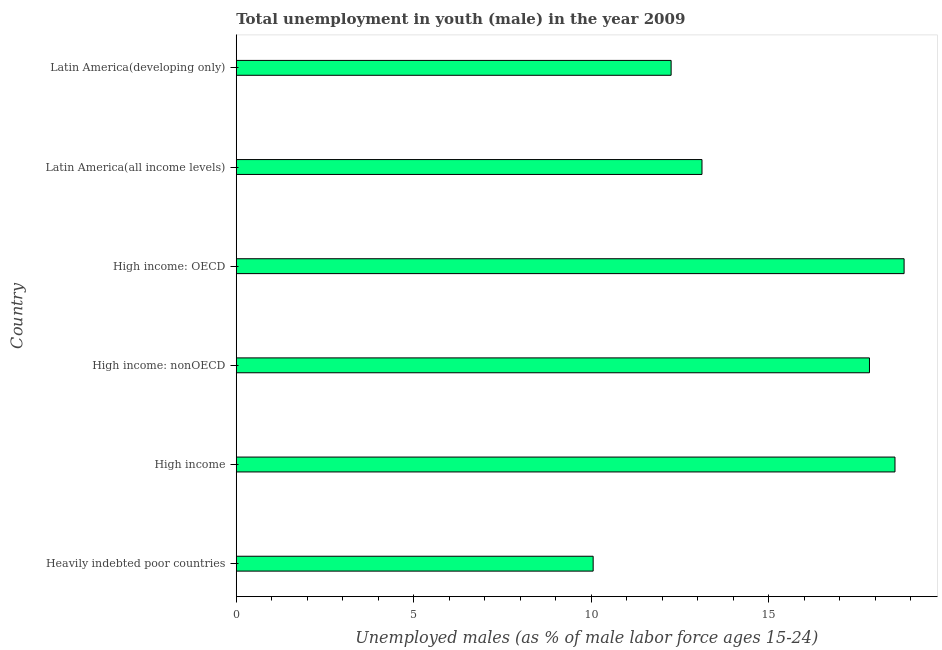Does the graph contain any zero values?
Offer a terse response. No. What is the title of the graph?
Provide a succinct answer. Total unemployment in youth (male) in the year 2009. What is the label or title of the X-axis?
Make the answer very short. Unemployed males (as % of male labor force ages 15-24). What is the unemployed male youth population in Latin America(developing only)?
Ensure brevity in your answer.  12.25. Across all countries, what is the maximum unemployed male youth population?
Make the answer very short. 18.81. Across all countries, what is the minimum unemployed male youth population?
Your answer should be very brief. 10.05. In which country was the unemployed male youth population maximum?
Give a very brief answer. High income: OECD. In which country was the unemployed male youth population minimum?
Make the answer very short. Heavily indebted poor countries. What is the sum of the unemployed male youth population?
Provide a succinct answer. 90.61. What is the difference between the unemployed male youth population in High income and Latin America(developing only)?
Ensure brevity in your answer.  6.3. What is the average unemployed male youth population per country?
Your response must be concise. 15.1. What is the median unemployed male youth population?
Offer a terse response. 15.47. In how many countries, is the unemployed male youth population greater than 17 %?
Your answer should be compact. 3. What is the ratio of the unemployed male youth population in High income to that in Latin America(developing only)?
Make the answer very short. 1.51. What is the difference between the highest and the second highest unemployed male youth population?
Your answer should be very brief. 0.26. Is the sum of the unemployed male youth population in Latin America(all income levels) and Latin America(developing only) greater than the maximum unemployed male youth population across all countries?
Provide a succinct answer. Yes. What is the difference between the highest and the lowest unemployed male youth population?
Give a very brief answer. 8.76. Are all the bars in the graph horizontal?
Give a very brief answer. Yes. Are the values on the major ticks of X-axis written in scientific E-notation?
Ensure brevity in your answer.  No. What is the Unemployed males (as % of male labor force ages 15-24) of Heavily indebted poor countries?
Provide a succinct answer. 10.05. What is the Unemployed males (as % of male labor force ages 15-24) of High income?
Give a very brief answer. 18.55. What is the Unemployed males (as % of male labor force ages 15-24) of High income: nonOECD?
Ensure brevity in your answer.  17.83. What is the Unemployed males (as % of male labor force ages 15-24) in High income: OECD?
Ensure brevity in your answer.  18.81. What is the Unemployed males (as % of male labor force ages 15-24) of Latin America(all income levels)?
Provide a short and direct response. 13.12. What is the Unemployed males (as % of male labor force ages 15-24) in Latin America(developing only)?
Provide a short and direct response. 12.25. What is the difference between the Unemployed males (as % of male labor force ages 15-24) in Heavily indebted poor countries and High income?
Make the answer very short. -8.5. What is the difference between the Unemployed males (as % of male labor force ages 15-24) in Heavily indebted poor countries and High income: nonOECD?
Make the answer very short. -7.78. What is the difference between the Unemployed males (as % of male labor force ages 15-24) in Heavily indebted poor countries and High income: OECD?
Provide a short and direct response. -8.76. What is the difference between the Unemployed males (as % of male labor force ages 15-24) in Heavily indebted poor countries and Latin America(all income levels)?
Give a very brief answer. -3.06. What is the difference between the Unemployed males (as % of male labor force ages 15-24) in Heavily indebted poor countries and Latin America(developing only)?
Your response must be concise. -2.2. What is the difference between the Unemployed males (as % of male labor force ages 15-24) in High income and High income: nonOECD?
Provide a short and direct response. 0.72. What is the difference between the Unemployed males (as % of male labor force ages 15-24) in High income and High income: OECD?
Provide a succinct answer. -0.26. What is the difference between the Unemployed males (as % of male labor force ages 15-24) in High income and Latin America(all income levels)?
Offer a terse response. 5.44. What is the difference between the Unemployed males (as % of male labor force ages 15-24) in High income and Latin America(developing only)?
Keep it short and to the point. 6.3. What is the difference between the Unemployed males (as % of male labor force ages 15-24) in High income: nonOECD and High income: OECD?
Keep it short and to the point. -0.98. What is the difference between the Unemployed males (as % of male labor force ages 15-24) in High income: nonOECD and Latin America(all income levels)?
Offer a terse response. 4.72. What is the difference between the Unemployed males (as % of male labor force ages 15-24) in High income: nonOECD and Latin America(developing only)?
Keep it short and to the point. 5.59. What is the difference between the Unemployed males (as % of male labor force ages 15-24) in High income: OECD and Latin America(all income levels)?
Your answer should be very brief. 5.69. What is the difference between the Unemployed males (as % of male labor force ages 15-24) in High income: OECD and Latin America(developing only)?
Offer a very short reply. 6.56. What is the difference between the Unemployed males (as % of male labor force ages 15-24) in Latin America(all income levels) and Latin America(developing only)?
Make the answer very short. 0.87. What is the ratio of the Unemployed males (as % of male labor force ages 15-24) in Heavily indebted poor countries to that in High income?
Offer a terse response. 0.54. What is the ratio of the Unemployed males (as % of male labor force ages 15-24) in Heavily indebted poor countries to that in High income: nonOECD?
Give a very brief answer. 0.56. What is the ratio of the Unemployed males (as % of male labor force ages 15-24) in Heavily indebted poor countries to that in High income: OECD?
Offer a terse response. 0.53. What is the ratio of the Unemployed males (as % of male labor force ages 15-24) in Heavily indebted poor countries to that in Latin America(all income levels)?
Offer a terse response. 0.77. What is the ratio of the Unemployed males (as % of male labor force ages 15-24) in Heavily indebted poor countries to that in Latin America(developing only)?
Offer a very short reply. 0.82. What is the ratio of the Unemployed males (as % of male labor force ages 15-24) in High income to that in High income: nonOECD?
Give a very brief answer. 1.04. What is the ratio of the Unemployed males (as % of male labor force ages 15-24) in High income to that in High income: OECD?
Provide a succinct answer. 0.99. What is the ratio of the Unemployed males (as % of male labor force ages 15-24) in High income to that in Latin America(all income levels)?
Your answer should be very brief. 1.41. What is the ratio of the Unemployed males (as % of male labor force ages 15-24) in High income to that in Latin America(developing only)?
Offer a very short reply. 1.51. What is the ratio of the Unemployed males (as % of male labor force ages 15-24) in High income: nonOECD to that in High income: OECD?
Ensure brevity in your answer.  0.95. What is the ratio of the Unemployed males (as % of male labor force ages 15-24) in High income: nonOECD to that in Latin America(all income levels)?
Make the answer very short. 1.36. What is the ratio of the Unemployed males (as % of male labor force ages 15-24) in High income: nonOECD to that in Latin America(developing only)?
Your answer should be very brief. 1.46. What is the ratio of the Unemployed males (as % of male labor force ages 15-24) in High income: OECD to that in Latin America(all income levels)?
Ensure brevity in your answer.  1.43. What is the ratio of the Unemployed males (as % of male labor force ages 15-24) in High income: OECD to that in Latin America(developing only)?
Offer a terse response. 1.54. What is the ratio of the Unemployed males (as % of male labor force ages 15-24) in Latin America(all income levels) to that in Latin America(developing only)?
Offer a terse response. 1.07. 